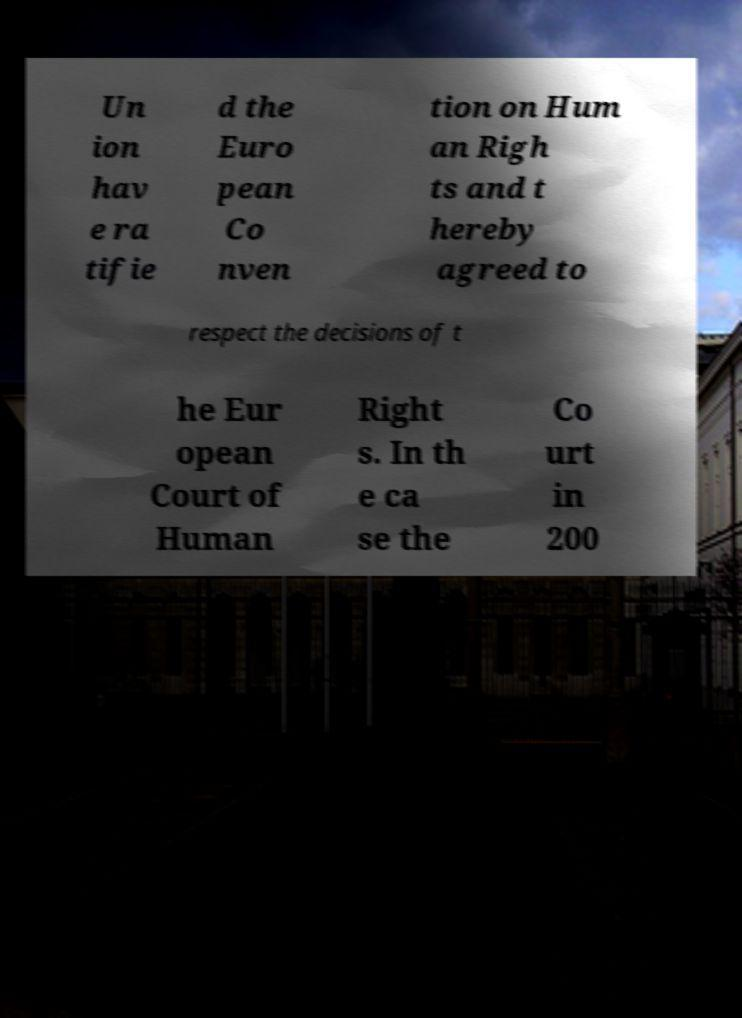Please read and relay the text visible in this image. What does it say? Un ion hav e ra tifie d the Euro pean Co nven tion on Hum an Righ ts and t hereby agreed to respect the decisions of t he Eur opean Court of Human Right s. In th e ca se the Co urt in 200 